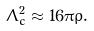Convert formula to latex. <formula><loc_0><loc_0><loc_500><loc_500>\Lambda ^ { 2 } _ { c } \approx 1 6 \pi \rho .</formula> 